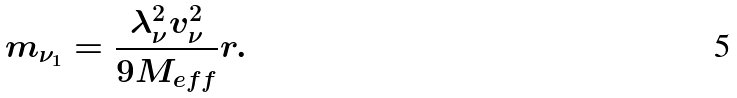Convert formula to latex. <formula><loc_0><loc_0><loc_500><loc_500>m _ { \nu _ { 1 } } = \frac { \lambda ^ { 2 } _ { \nu } v ^ { 2 } _ { \nu } } { 9 M _ { e f f } } r .</formula> 